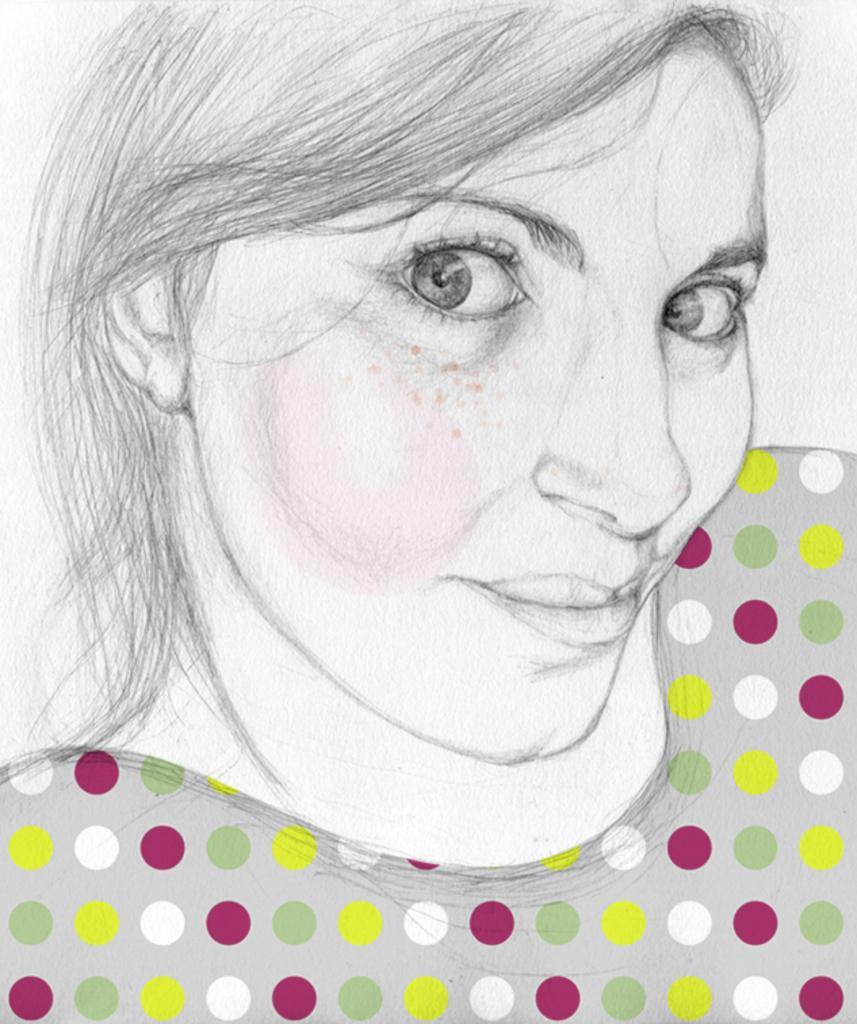Please provide a concise description of this image. In the image we can see there is a drawing of a women. 